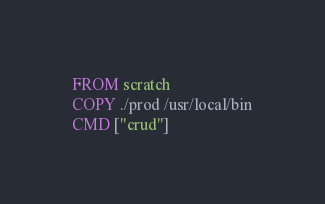Convert code to text. <code><loc_0><loc_0><loc_500><loc_500><_Dockerfile_>FROM scratch
COPY ./prod /usr/local/bin
CMD ["crud"]</code> 